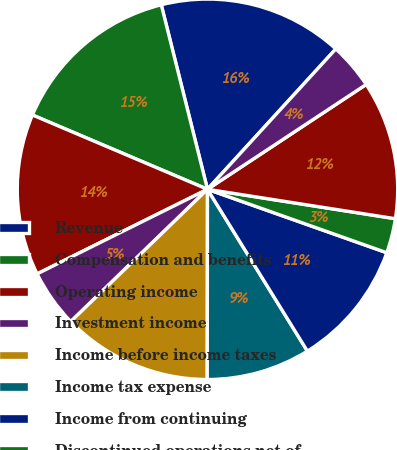Convert chart to OTSL. <chart><loc_0><loc_0><loc_500><loc_500><pie_chart><fcel>Revenue<fcel>Compensation and benefits<fcel>Operating income<fcel>Investment income<fcel>Income before income taxes<fcel>Income tax expense<fcel>Income from continuing<fcel>Discontinued operations net of<fcel>Net income before<fcel>Less Net income attributable<nl><fcel>15.69%<fcel>14.7%<fcel>13.72%<fcel>4.9%<fcel>12.74%<fcel>8.82%<fcel>10.78%<fcel>2.94%<fcel>11.76%<fcel>3.92%<nl></chart> 